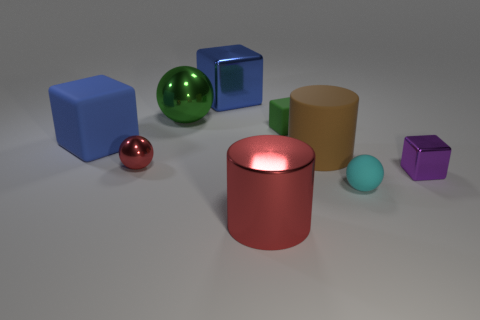Subtract all tiny spheres. How many spheres are left? 1 Add 1 small brown objects. How many objects exist? 10 Subtract all blue cubes. How many cubes are left? 2 Subtract all cylinders. How many objects are left? 7 Subtract 0 blue cylinders. How many objects are left? 9 Subtract 2 spheres. How many spheres are left? 1 Subtract all yellow cylinders. Subtract all blue cubes. How many cylinders are left? 2 Subtract all brown cylinders. How many red balls are left? 1 Subtract all purple blocks. Subtract all big green metallic things. How many objects are left? 7 Add 9 small green rubber blocks. How many small green rubber blocks are left? 10 